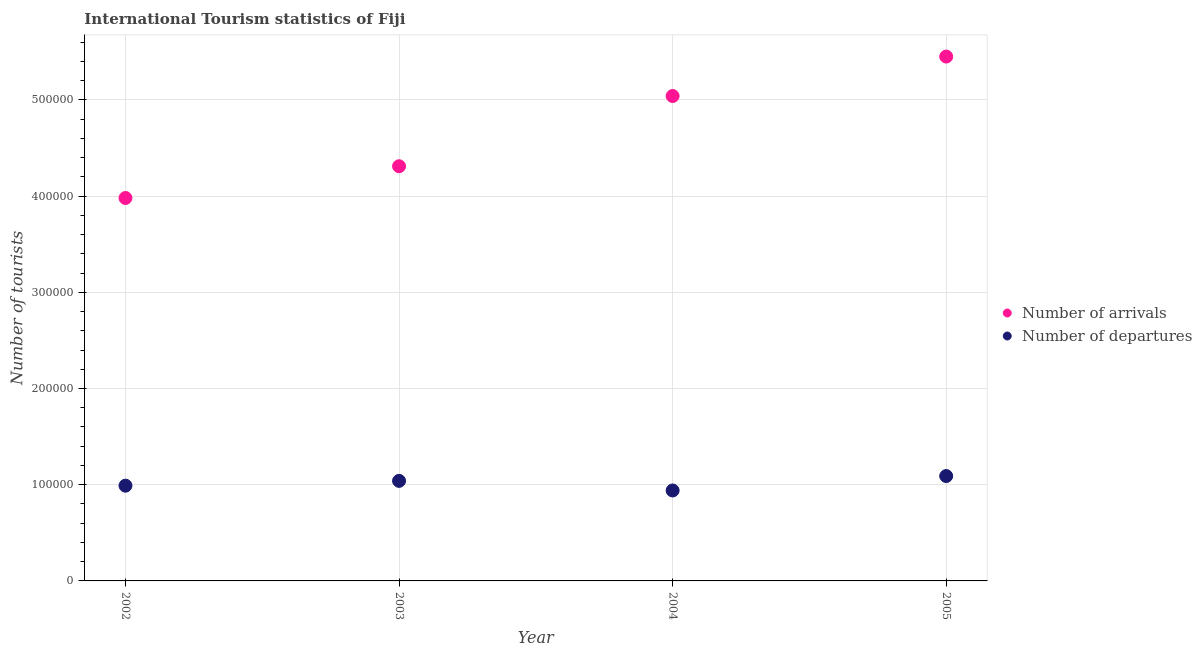What is the number of tourist arrivals in 2003?
Make the answer very short. 4.31e+05. Across all years, what is the maximum number of tourist arrivals?
Offer a very short reply. 5.45e+05. Across all years, what is the minimum number of tourist departures?
Provide a short and direct response. 9.40e+04. In which year was the number of tourist arrivals minimum?
Make the answer very short. 2002. What is the total number of tourist departures in the graph?
Your answer should be compact. 4.06e+05. What is the difference between the number of tourist arrivals in 2002 and that in 2004?
Offer a terse response. -1.06e+05. What is the difference between the number of tourist arrivals in 2003 and the number of tourist departures in 2002?
Provide a succinct answer. 3.32e+05. What is the average number of tourist arrivals per year?
Provide a short and direct response. 4.70e+05. In the year 2005, what is the difference between the number of tourist arrivals and number of tourist departures?
Offer a very short reply. 4.36e+05. In how many years, is the number of tourist departures greater than 420000?
Your answer should be very brief. 0. What is the ratio of the number of tourist departures in 2004 to that in 2005?
Give a very brief answer. 0.86. What is the difference between the highest and the second highest number of tourist arrivals?
Give a very brief answer. 4.10e+04. What is the difference between the highest and the lowest number of tourist arrivals?
Your answer should be compact. 1.47e+05. In how many years, is the number of tourist departures greater than the average number of tourist departures taken over all years?
Keep it short and to the point. 2. Is the number of tourist arrivals strictly greater than the number of tourist departures over the years?
Make the answer very short. Yes. Is the number of tourist departures strictly less than the number of tourist arrivals over the years?
Your answer should be compact. Yes. Does the graph contain any zero values?
Provide a succinct answer. No. Where does the legend appear in the graph?
Provide a short and direct response. Center right. How many legend labels are there?
Your response must be concise. 2. How are the legend labels stacked?
Offer a terse response. Vertical. What is the title of the graph?
Ensure brevity in your answer.  International Tourism statistics of Fiji. Does "Import" appear as one of the legend labels in the graph?
Ensure brevity in your answer.  No. What is the label or title of the X-axis?
Provide a short and direct response. Year. What is the label or title of the Y-axis?
Provide a short and direct response. Number of tourists. What is the Number of tourists in Number of arrivals in 2002?
Offer a terse response. 3.98e+05. What is the Number of tourists of Number of departures in 2002?
Keep it short and to the point. 9.90e+04. What is the Number of tourists in Number of arrivals in 2003?
Your response must be concise. 4.31e+05. What is the Number of tourists in Number of departures in 2003?
Ensure brevity in your answer.  1.04e+05. What is the Number of tourists in Number of arrivals in 2004?
Ensure brevity in your answer.  5.04e+05. What is the Number of tourists of Number of departures in 2004?
Keep it short and to the point. 9.40e+04. What is the Number of tourists in Number of arrivals in 2005?
Give a very brief answer. 5.45e+05. What is the Number of tourists of Number of departures in 2005?
Your answer should be very brief. 1.09e+05. Across all years, what is the maximum Number of tourists of Number of arrivals?
Your response must be concise. 5.45e+05. Across all years, what is the maximum Number of tourists in Number of departures?
Make the answer very short. 1.09e+05. Across all years, what is the minimum Number of tourists of Number of arrivals?
Offer a terse response. 3.98e+05. Across all years, what is the minimum Number of tourists of Number of departures?
Make the answer very short. 9.40e+04. What is the total Number of tourists in Number of arrivals in the graph?
Offer a very short reply. 1.88e+06. What is the total Number of tourists in Number of departures in the graph?
Offer a very short reply. 4.06e+05. What is the difference between the Number of tourists in Number of arrivals in 2002 and that in 2003?
Provide a short and direct response. -3.30e+04. What is the difference between the Number of tourists in Number of departures in 2002 and that in 2003?
Offer a terse response. -5000. What is the difference between the Number of tourists in Number of arrivals in 2002 and that in 2004?
Give a very brief answer. -1.06e+05. What is the difference between the Number of tourists in Number of departures in 2002 and that in 2004?
Your response must be concise. 5000. What is the difference between the Number of tourists in Number of arrivals in 2002 and that in 2005?
Provide a short and direct response. -1.47e+05. What is the difference between the Number of tourists of Number of arrivals in 2003 and that in 2004?
Provide a succinct answer. -7.30e+04. What is the difference between the Number of tourists of Number of departures in 2003 and that in 2004?
Provide a short and direct response. 10000. What is the difference between the Number of tourists in Number of arrivals in 2003 and that in 2005?
Make the answer very short. -1.14e+05. What is the difference between the Number of tourists of Number of departures in 2003 and that in 2005?
Your answer should be compact. -5000. What is the difference between the Number of tourists in Number of arrivals in 2004 and that in 2005?
Ensure brevity in your answer.  -4.10e+04. What is the difference between the Number of tourists in Number of departures in 2004 and that in 2005?
Give a very brief answer. -1.50e+04. What is the difference between the Number of tourists in Number of arrivals in 2002 and the Number of tourists in Number of departures in 2003?
Provide a succinct answer. 2.94e+05. What is the difference between the Number of tourists in Number of arrivals in 2002 and the Number of tourists in Number of departures in 2004?
Your answer should be compact. 3.04e+05. What is the difference between the Number of tourists in Number of arrivals in 2002 and the Number of tourists in Number of departures in 2005?
Your answer should be very brief. 2.89e+05. What is the difference between the Number of tourists of Number of arrivals in 2003 and the Number of tourists of Number of departures in 2004?
Ensure brevity in your answer.  3.37e+05. What is the difference between the Number of tourists in Number of arrivals in 2003 and the Number of tourists in Number of departures in 2005?
Keep it short and to the point. 3.22e+05. What is the difference between the Number of tourists in Number of arrivals in 2004 and the Number of tourists in Number of departures in 2005?
Make the answer very short. 3.95e+05. What is the average Number of tourists in Number of arrivals per year?
Provide a succinct answer. 4.70e+05. What is the average Number of tourists in Number of departures per year?
Keep it short and to the point. 1.02e+05. In the year 2002, what is the difference between the Number of tourists of Number of arrivals and Number of tourists of Number of departures?
Provide a succinct answer. 2.99e+05. In the year 2003, what is the difference between the Number of tourists in Number of arrivals and Number of tourists in Number of departures?
Offer a very short reply. 3.27e+05. In the year 2005, what is the difference between the Number of tourists of Number of arrivals and Number of tourists of Number of departures?
Ensure brevity in your answer.  4.36e+05. What is the ratio of the Number of tourists of Number of arrivals in 2002 to that in 2003?
Offer a very short reply. 0.92. What is the ratio of the Number of tourists of Number of departures in 2002 to that in 2003?
Give a very brief answer. 0.95. What is the ratio of the Number of tourists in Number of arrivals in 2002 to that in 2004?
Your response must be concise. 0.79. What is the ratio of the Number of tourists of Number of departures in 2002 to that in 2004?
Give a very brief answer. 1.05. What is the ratio of the Number of tourists of Number of arrivals in 2002 to that in 2005?
Offer a very short reply. 0.73. What is the ratio of the Number of tourists of Number of departures in 2002 to that in 2005?
Ensure brevity in your answer.  0.91. What is the ratio of the Number of tourists in Number of arrivals in 2003 to that in 2004?
Your answer should be compact. 0.86. What is the ratio of the Number of tourists in Number of departures in 2003 to that in 2004?
Your answer should be very brief. 1.11. What is the ratio of the Number of tourists of Number of arrivals in 2003 to that in 2005?
Your response must be concise. 0.79. What is the ratio of the Number of tourists of Number of departures in 2003 to that in 2005?
Offer a very short reply. 0.95. What is the ratio of the Number of tourists in Number of arrivals in 2004 to that in 2005?
Your response must be concise. 0.92. What is the ratio of the Number of tourists in Number of departures in 2004 to that in 2005?
Keep it short and to the point. 0.86. What is the difference between the highest and the second highest Number of tourists in Number of arrivals?
Offer a terse response. 4.10e+04. What is the difference between the highest and the lowest Number of tourists in Number of arrivals?
Ensure brevity in your answer.  1.47e+05. What is the difference between the highest and the lowest Number of tourists in Number of departures?
Provide a succinct answer. 1.50e+04. 